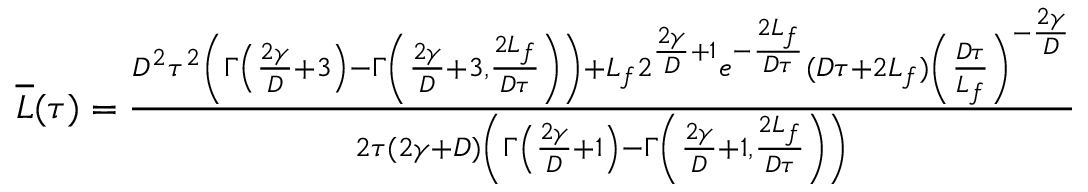<formula> <loc_0><loc_0><loc_500><loc_500>\begin{array} { r } { \overline { L } ( \tau ) = \frac { D ^ { 2 } \tau ^ { 2 } \left ( \Gamma \left ( \frac { 2 \gamma } { D } + 3 \right ) - \Gamma \left ( \frac { 2 \gamma } { D } + 3 , \frac { 2 L _ { f } } { D \tau } \right ) \right ) + L _ { f } 2 ^ { \frac { 2 \gamma } { D } + 1 } e ^ { - \frac { 2 L _ { f } } { D \tau } } ( D \tau + 2 L _ { f } ) \left ( \frac { D \tau } { L _ { f } } \right ) ^ { - \frac { 2 \gamma } { D } } } { 2 \tau ( 2 \gamma + D ) \left ( \Gamma \left ( \frac { 2 \gamma } { D } + 1 \right ) - \Gamma \left ( \frac { 2 \gamma } { D } + 1 , \frac { 2 L _ { f } } { D \tau } \right ) \right ) } } \end{array}</formula> 